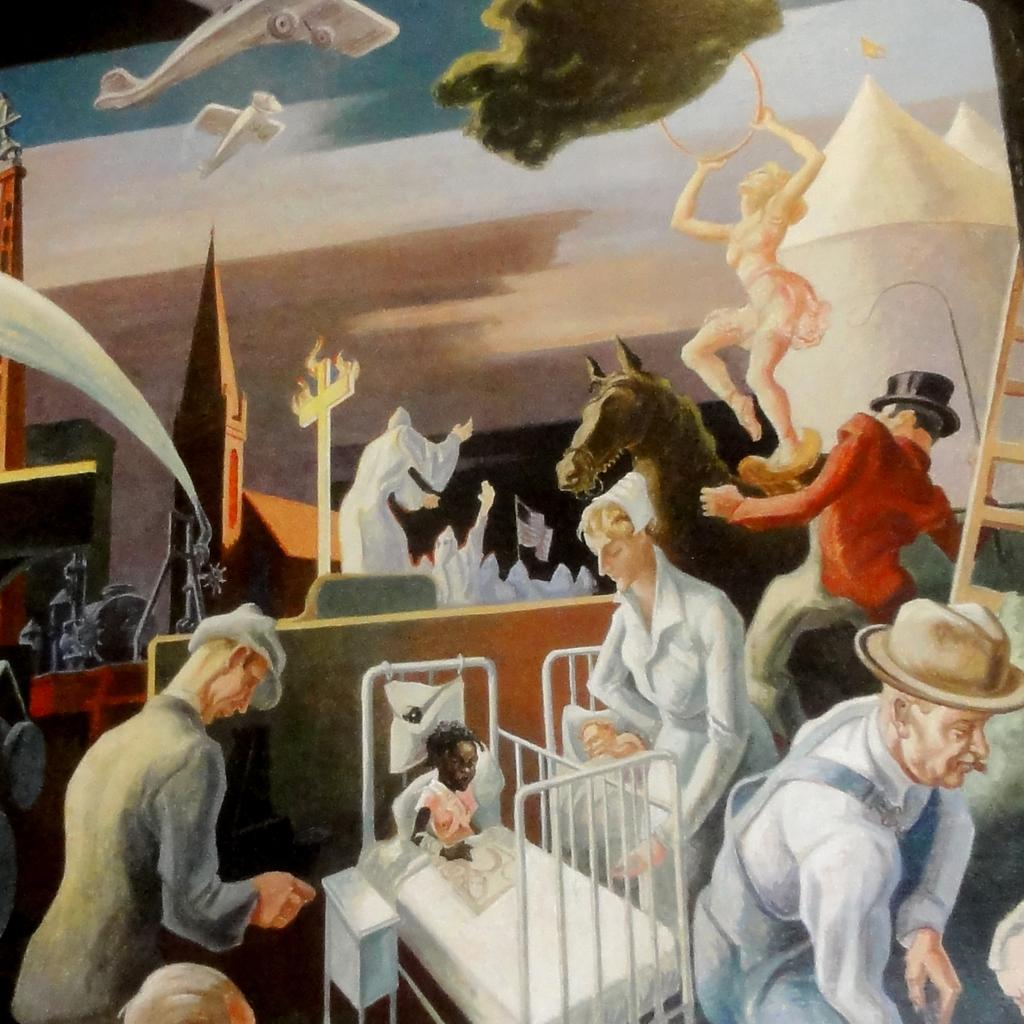What type of artwork is depicted in the image? The image is a painting. What can be seen in the painting? There are persons present in the painting, along with a bed, a table, a ladder, an aeroplane, and a building. What is the sky's condition in the painting? The sky is visible at the top of the painting. What type of yam is being used as a roof in the painting? There is no yam present in the painting, and no roof made of yam can be observed. 